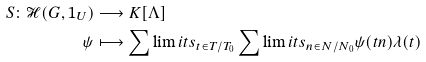<formula> <loc_0><loc_0><loc_500><loc_500>S \colon \mathcal { H } ( G , 1 _ { U } ) & \longrightarrow K [ \Lambda ] \\ \psi & \longmapsto \sum \lim i t s _ { t \in T / T _ { 0 } } \sum \lim i t s _ { n \in N / N _ { 0 } } \psi ( t n ) \lambda ( t )</formula> 